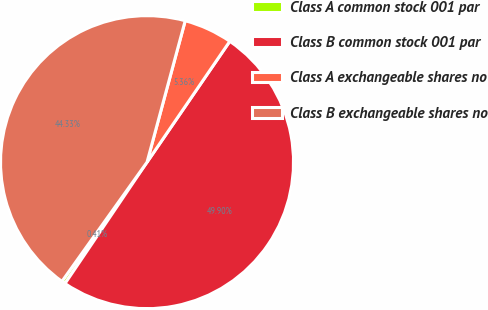Convert chart to OTSL. <chart><loc_0><loc_0><loc_500><loc_500><pie_chart><fcel>Class A common stock 001 par<fcel>Class B common stock 001 par<fcel>Class A exchangeable shares no<fcel>Class B exchangeable shares no<nl><fcel>0.41%<fcel>49.9%<fcel>5.36%<fcel>44.33%<nl></chart> 